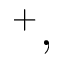<formula> <loc_0><loc_0><loc_500><loc_500>^ { + } ,</formula> 